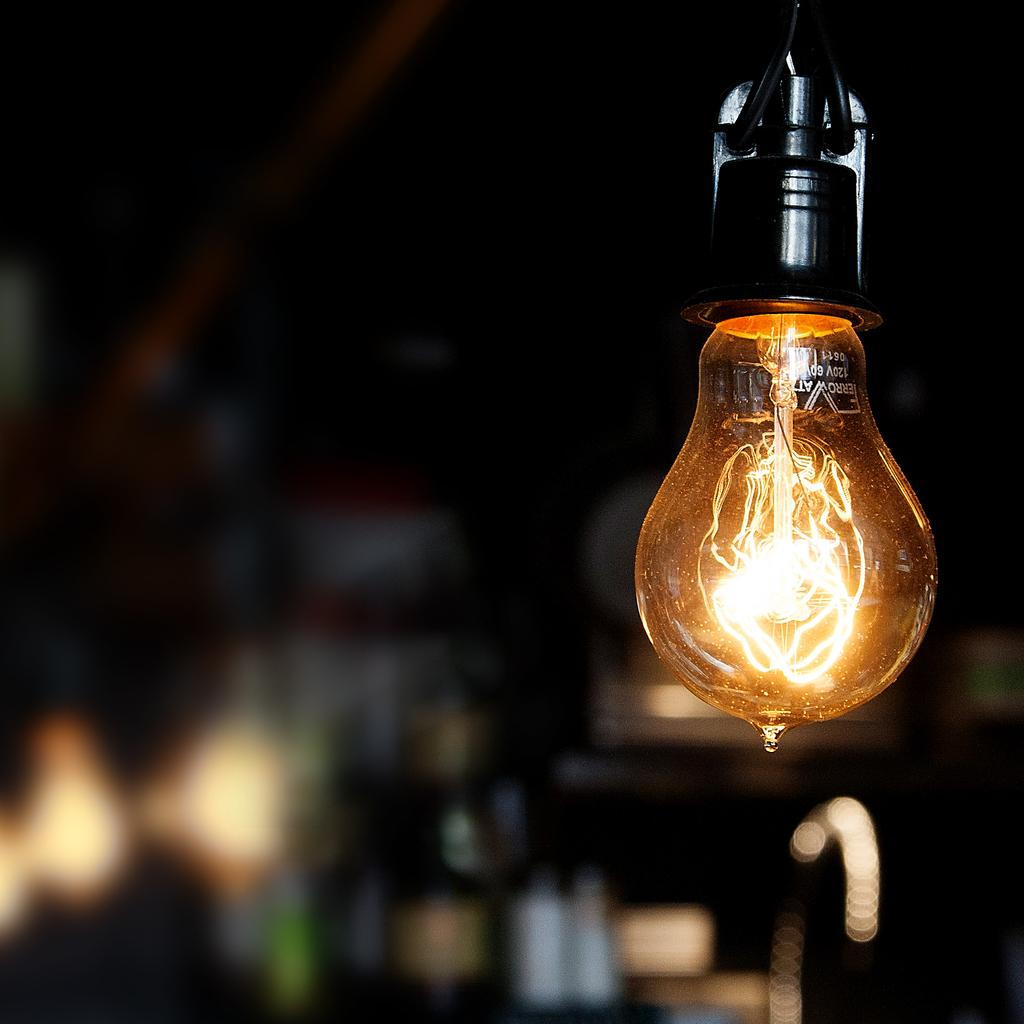What object is the main focus of the image? There is a bulb in the image. What is the state of the bulb in the image? The bulb is glowing. How would you describe the background of the image? The background of the image is blurred. What book is the person reading in the image? There is no person or book present in the image; it only features a glowing bulb with a blurred background. 